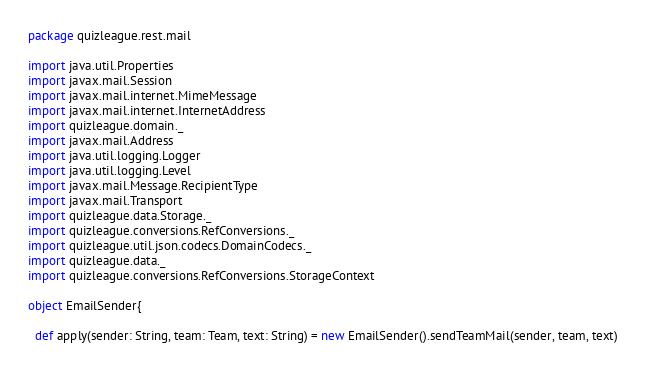<code> <loc_0><loc_0><loc_500><loc_500><_Scala_>package quizleague.rest.mail

import java.util.Properties
import javax.mail.Session
import javax.mail.internet.MimeMessage
import javax.mail.internet.InternetAddress
import quizleague.domain._
import javax.mail.Address
import java.util.logging.Logger
import java.util.logging.Level
import javax.mail.Message.RecipientType
import javax.mail.Transport
import quizleague.data.Storage._
import quizleague.conversions.RefConversions._
import quizleague.util.json.codecs.DomainCodecs._
import quizleague.data._
import quizleague.conversions.RefConversions.StorageContext

object EmailSender{
  
  def apply(sender: String, team: Team, text: String) = new EmailSender().sendTeamMail(sender, team, text)
 </code> 